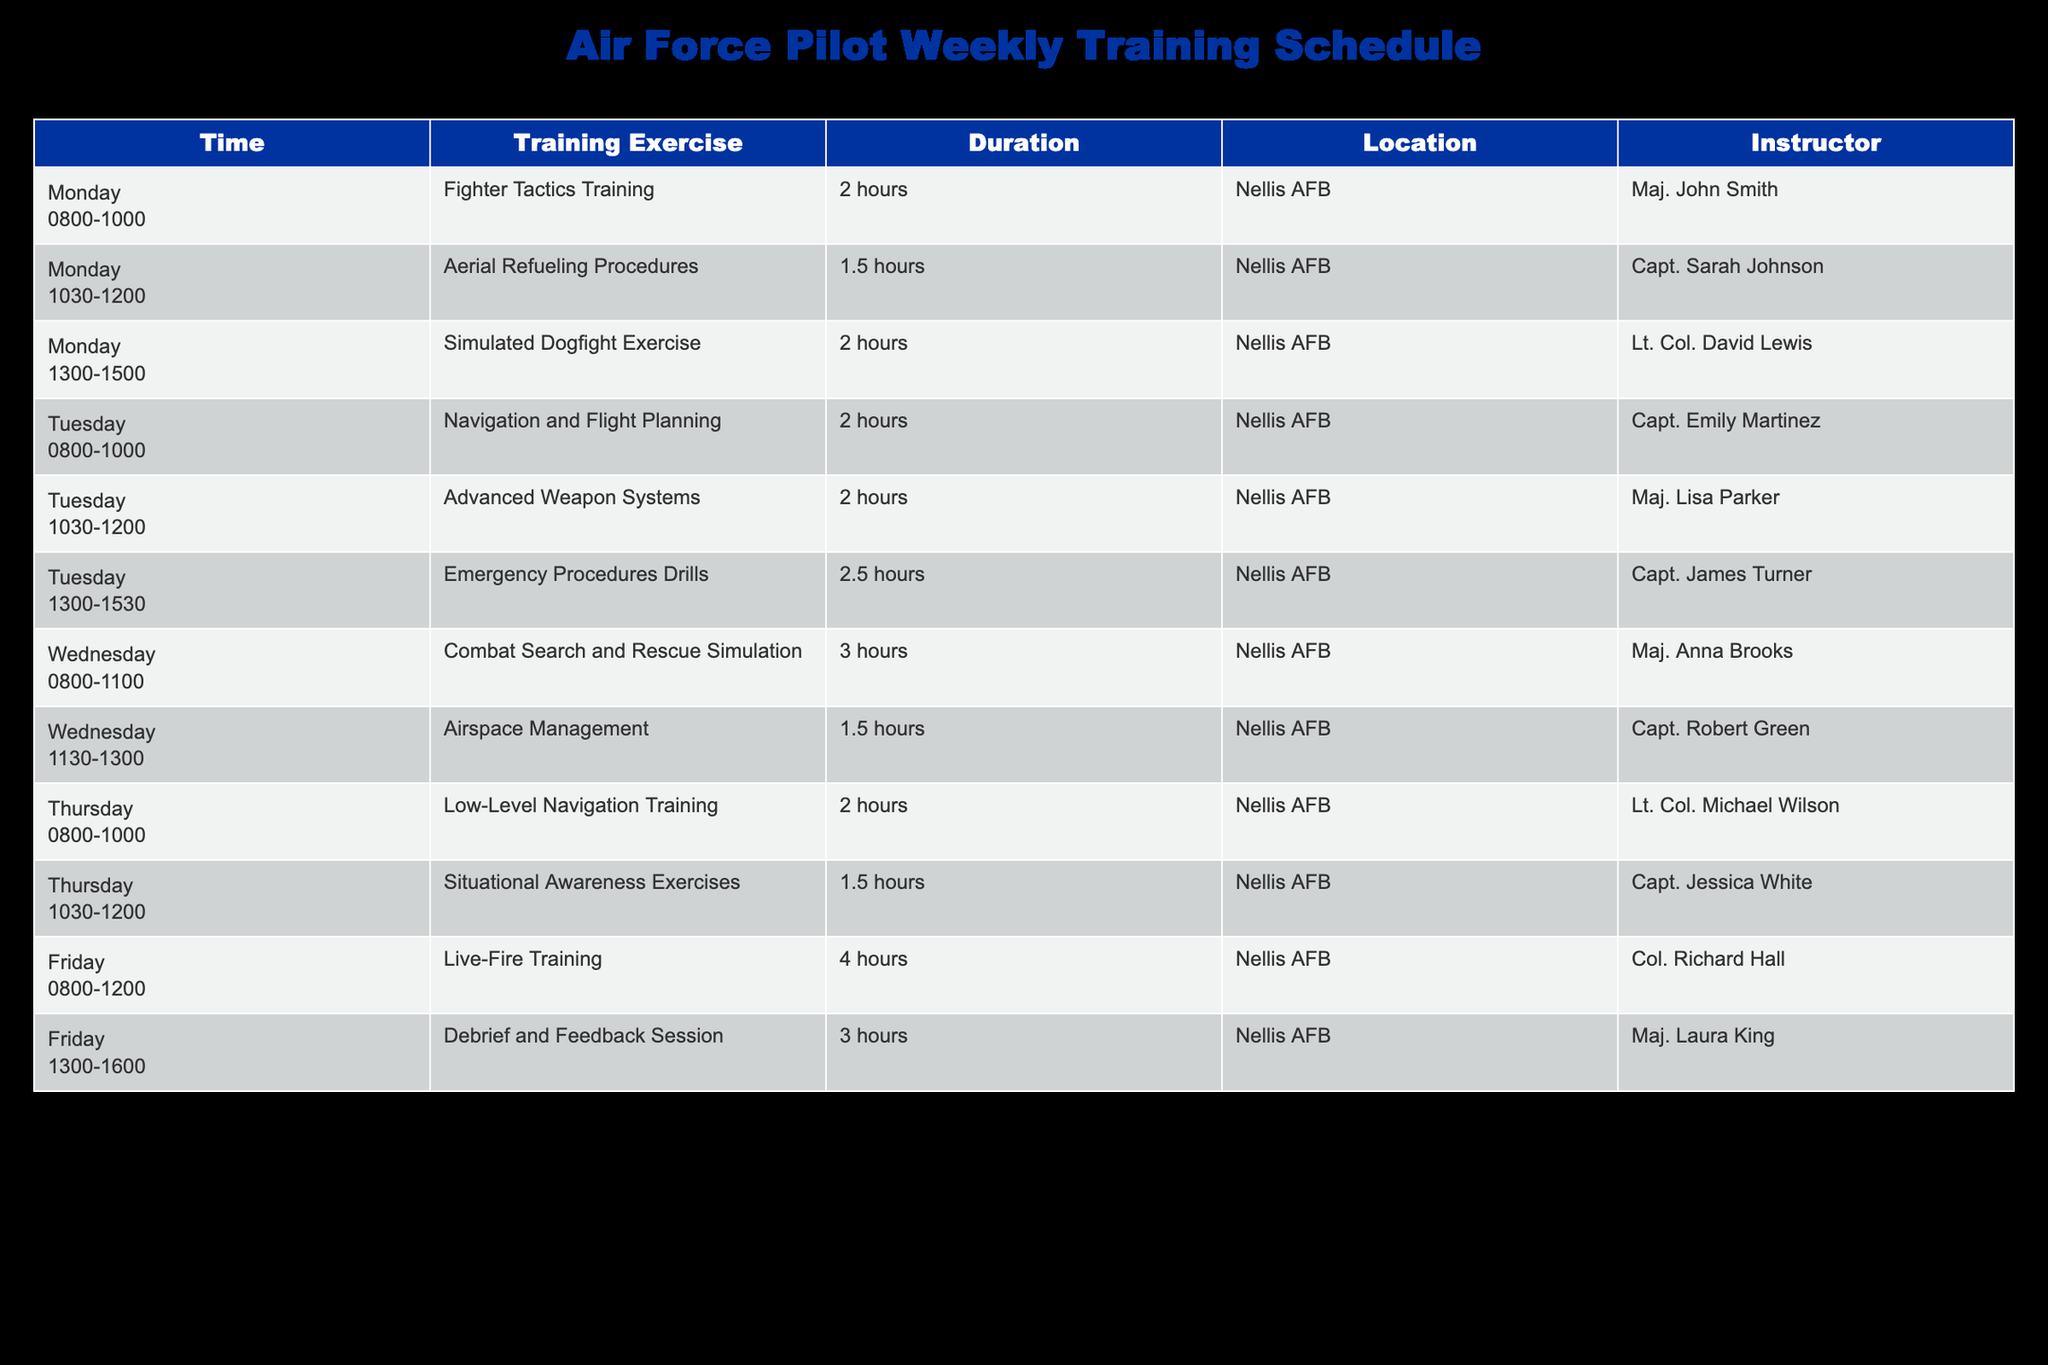What training exercise is scheduled on Wednesday at 0800? The table indicates that on Wednesday, the training exercise scheduled at 0800 is "Combat Search and Rescue Simulation."
Answer: Combat Search and Rescue Simulation How long is the "Live-Fire Training" exercise? Referring to the table, "Live-Fire Training" on Friday is scheduled for 4 hours.
Answer: 4 hours Which instructor is responsible for "Aerial Refueling Procedures"? The table shows that "Aerial Refueling Procedures" is taught by Capt. Sarah Johnson on Monday from 1030 to 1200.
Answer: Capt. Sarah Johnson On which day do pilots have the longest training session, and how long is it? By comparing the training durations, the longest session is "Live-Fire Training," which lasts for 4 hours on Friday.
Answer: Friday, 4 hours Is there any session on Thursday after 1200? The table lists all training sessions, and on Thursday, the last session ends at 1200. Therefore, there are no sessions after 1200 on that day.
Answer: No What is the total duration of training sessions on Tuesday? Tuesday has three training sessions: 2 hours for "Navigation and Flight Planning," 2 hours for "Advanced Weapon Systems," and 2.5 hours for "Emergency Procedures Drills." Summing these (2 + 2 + 2.5), the total duration is 6.5 hours.
Answer: 6.5 hours How many different instructors are listed in the table? The table lists instructors for each training session; they are Maj. John Smith, Capt. Sarah Johnson, Lt. Col. David Lewis, Capt. Emily Martinez, Maj. Lisa Parker, Capt. James Turner, Maj. Anna Brooks, Capt. Robert Green, Lt. Col. Michael Wilson, Capt. Jessica White, Col. Richard Hall, and Maj. Laura King. Counting them gives a total of 12 different instructors.
Answer: 12 What is the average duration of the training exercises on Monday? Monday has three exercises: "Fighter Tactics Training" for 2 hours, "Aerial Refueling Procedures" for 1.5 hours, and "Simulated Dogfight Exercise" for 2 hours. The total duration is (2 + 1.5 + 2) = 5.5 hours. The average is calculated by dividing this total by the number of exercises (5.5 / 3), which equals approximately 1.83 hours.
Answer: 1.83 hours Does any training exercise occur at the same time on Tuesday? Reviewing the table, there are no overlapping times for the training exercises on Tuesday; each session begins after the previous one has ended.
Answer: No 